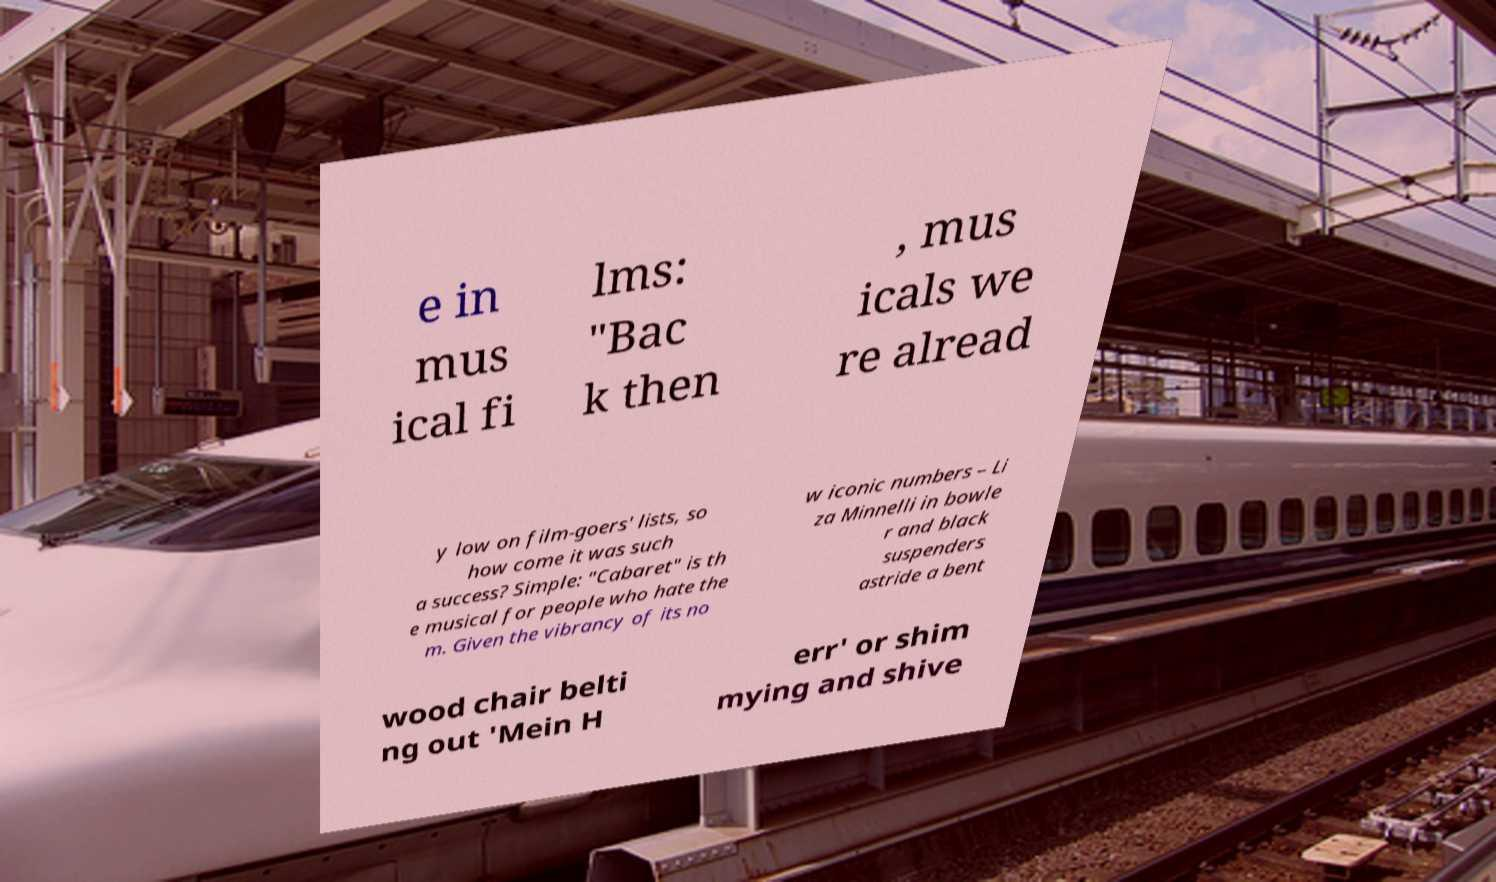Can you read and provide the text displayed in the image?This photo seems to have some interesting text. Can you extract and type it out for me? e in mus ical fi lms: "Bac k then , mus icals we re alread y low on film-goers' lists, so how come it was such a success? Simple: "Cabaret" is th e musical for people who hate the m. Given the vibrancy of its no w iconic numbers – Li za Minnelli in bowle r and black suspenders astride a bent wood chair belti ng out 'Mein H err' or shim mying and shive 